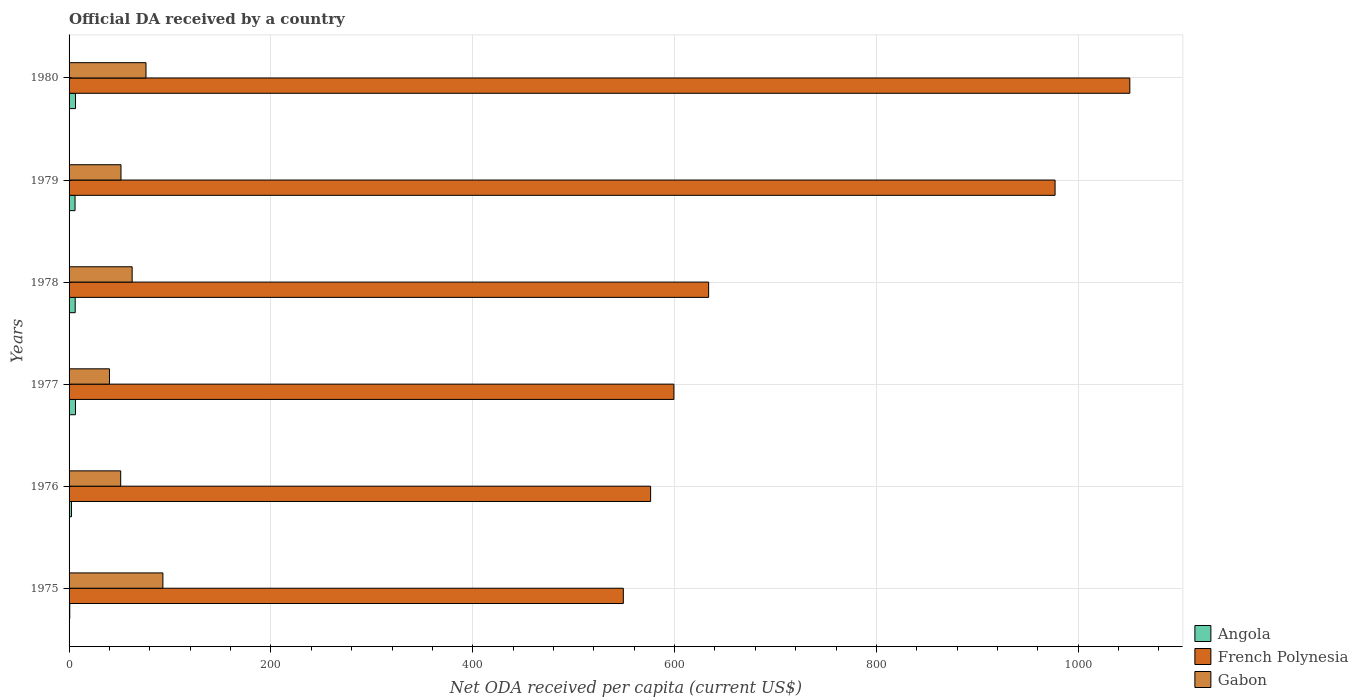How many groups of bars are there?
Your answer should be compact. 6. Are the number of bars per tick equal to the number of legend labels?
Give a very brief answer. Yes. What is the label of the 5th group of bars from the top?
Your answer should be very brief. 1976. What is the ODA received in in Gabon in 1979?
Your response must be concise. 51.47. Across all years, what is the maximum ODA received in in Gabon?
Offer a terse response. 92.96. Across all years, what is the minimum ODA received in in French Polynesia?
Make the answer very short. 549.23. In which year was the ODA received in in French Polynesia maximum?
Keep it short and to the point. 1980. What is the total ODA received in in Gabon in the graph?
Ensure brevity in your answer.  374.36. What is the difference between the ODA received in in French Polynesia in 1976 and that in 1980?
Your answer should be compact. -474.86. What is the difference between the ODA received in in Gabon in 1979 and the ODA received in in French Polynesia in 1980?
Keep it short and to the point. -999.67. What is the average ODA received in in Gabon per year?
Offer a very short reply. 62.39. In the year 1979, what is the difference between the ODA received in in Angola and ODA received in in French Polynesia?
Offer a terse response. -971.14. What is the ratio of the ODA received in in French Polynesia in 1975 to that in 1980?
Provide a succinct answer. 0.52. Is the ODA received in in French Polynesia in 1976 less than that in 1980?
Your answer should be very brief. Yes. Is the difference between the ODA received in in Angola in 1976 and 1980 greater than the difference between the ODA received in in French Polynesia in 1976 and 1980?
Your answer should be very brief. Yes. What is the difference between the highest and the second highest ODA received in in French Polynesia?
Provide a succinct answer. 74.08. What is the difference between the highest and the lowest ODA received in in Angola?
Offer a very short reply. 5.72. In how many years, is the ODA received in in French Polynesia greater than the average ODA received in in French Polynesia taken over all years?
Offer a terse response. 2. Is the sum of the ODA received in in French Polynesia in 1975 and 1980 greater than the maximum ODA received in in Angola across all years?
Make the answer very short. Yes. What does the 2nd bar from the top in 1976 represents?
Your answer should be compact. French Polynesia. What does the 1st bar from the bottom in 1975 represents?
Offer a very short reply. Angola. How many bars are there?
Offer a terse response. 18. Are the values on the major ticks of X-axis written in scientific E-notation?
Provide a short and direct response. No. Does the graph contain grids?
Offer a very short reply. Yes. How many legend labels are there?
Your answer should be very brief. 3. What is the title of the graph?
Your response must be concise. Official DA received by a country. Does "Costa Rica" appear as one of the legend labels in the graph?
Provide a succinct answer. No. What is the label or title of the X-axis?
Offer a very short reply. Net ODA received per capita (current US$). What is the Net ODA received per capita (current US$) of Angola in 1975?
Make the answer very short. 0.67. What is the Net ODA received per capita (current US$) of French Polynesia in 1975?
Your answer should be compact. 549.23. What is the Net ODA received per capita (current US$) of Gabon in 1975?
Give a very brief answer. 92.96. What is the Net ODA received per capita (current US$) of Angola in 1976?
Offer a terse response. 2.39. What is the Net ODA received per capita (current US$) of French Polynesia in 1976?
Your answer should be very brief. 576.28. What is the Net ODA received per capita (current US$) of Gabon in 1976?
Your response must be concise. 51.16. What is the Net ODA received per capita (current US$) of Angola in 1977?
Provide a short and direct response. 6.33. What is the Net ODA received per capita (current US$) of French Polynesia in 1977?
Make the answer very short. 599.35. What is the Net ODA received per capita (current US$) of Gabon in 1977?
Provide a succinct answer. 40.03. What is the Net ODA received per capita (current US$) in Angola in 1978?
Keep it short and to the point. 6.07. What is the Net ODA received per capita (current US$) in French Polynesia in 1978?
Keep it short and to the point. 633.77. What is the Net ODA received per capita (current US$) of Gabon in 1978?
Your response must be concise. 62.51. What is the Net ODA received per capita (current US$) in Angola in 1979?
Offer a terse response. 5.92. What is the Net ODA received per capita (current US$) of French Polynesia in 1979?
Provide a succinct answer. 977.06. What is the Net ODA received per capita (current US$) in Gabon in 1979?
Your answer should be very brief. 51.47. What is the Net ODA received per capita (current US$) of Angola in 1980?
Make the answer very short. 6.39. What is the Net ODA received per capita (current US$) in French Polynesia in 1980?
Make the answer very short. 1051.14. What is the Net ODA received per capita (current US$) of Gabon in 1980?
Give a very brief answer. 76.22. Across all years, what is the maximum Net ODA received per capita (current US$) in Angola?
Provide a succinct answer. 6.39. Across all years, what is the maximum Net ODA received per capita (current US$) of French Polynesia?
Give a very brief answer. 1051.14. Across all years, what is the maximum Net ODA received per capita (current US$) in Gabon?
Your response must be concise. 92.96. Across all years, what is the minimum Net ODA received per capita (current US$) of Angola?
Make the answer very short. 0.67. Across all years, what is the minimum Net ODA received per capita (current US$) of French Polynesia?
Keep it short and to the point. 549.23. Across all years, what is the minimum Net ODA received per capita (current US$) of Gabon?
Your answer should be very brief. 40.03. What is the total Net ODA received per capita (current US$) in Angola in the graph?
Offer a very short reply. 27.77. What is the total Net ODA received per capita (current US$) in French Polynesia in the graph?
Make the answer very short. 4386.83. What is the total Net ODA received per capita (current US$) in Gabon in the graph?
Give a very brief answer. 374.36. What is the difference between the Net ODA received per capita (current US$) of Angola in 1975 and that in 1976?
Offer a very short reply. -1.73. What is the difference between the Net ODA received per capita (current US$) in French Polynesia in 1975 and that in 1976?
Your answer should be compact. -27.05. What is the difference between the Net ODA received per capita (current US$) in Gabon in 1975 and that in 1976?
Offer a very short reply. 41.8. What is the difference between the Net ODA received per capita (current US$) in Angola in 1975 and that in 1977?
Offer a terse response. -5.66. What is the difference between the Net ODA received per capita (current US$) of French Polynesia in 1975 and that in 1977?
Your response must be concise. -50.12. What is the difference between the Net ODA received per capita (current US$) in Gabon in 1975 and that in 1977?
Your answer should be very brief. 52.94. What is the difference between the Net ODA received per capita (current US$) of Angola in 1975 and that in 1978?
Keep it short and to the point. -5.4. What is the difference between the Net ODA received per capita (current US$) of French Polynesia in 1975 and that in 1978?
Offer a very short reply. -84.54. What is the difference between the Net ODA received per capita (current US$) in Gabon in 1975 and that in 1978?
Offer a very short reply. 30.45. What is the difference between the Net ODA received per capita (current US$) of Angola in 1975 and that in 1979?
Provide a succinct answer. -5.25. What is the difference between the Net ODA received per capita (current US$) in French Polynesia in 1975 and that in 1979?
Your answer should be compact. -427.83. What is the difference between the Net ODA received per capita (current US$) of Gabon in 1975 and that in 1979?
Ensure brevity in your answer.  41.5. What is the difference between the Net ODA received per capita (current US$) in Angola in 1975 and that in 1980?
Your response must be concise. -5.72. What is the difference between the Net ODA received per capita (current US$) in French Polynesia in 1975 and that in 1980?
Provide a succinct answer. -501.91. What is the difference between the Net ODA received per capita (current US$) of Gabon in 1975 and that in 1980?
Offer a very short reply. 16.74. What is the difference between the Net ODA received per capita (current US$) in Angola in 1976 and that in 1977?
Offer a very short reply. -3.94. What is the difference between the Net ODA received per capita (current US$) in French Polynesia in 1976 and that in 1977?
Ensure brevity in your answer.  -23.07. What is the difference between the Net ODA received per capita (current US$) of Gabon in 1976 and that in 1977?
Provide a succinct answer. 11.13. What is the difference between the Net ODA received per capita (current US$) of Angola in 1976 and that in 1978?
Ensure brevity in your answer.  -3.68. What is the difference between the Net ODA received per capita (current US$) in French Polynesia in 1976 and that in 1978?
Provide a short and direct response. -57.49. What is the difference between the Net ODA received per capita (current US$) in Gabon in 1976 and that in 1978?
Give a very brief answer. -11.35. What is the difference between the Net ODA received per capita (current US$) in Angola in 1976 and that in 1979?
Offer a terse response. -3.52. What is the difference between the Net ODA received per capita (current US$) in French Polynesia in 1976 and that in 1979?
Offer a very short reply. -400.78. What is the difference between the Net ODA received per capita (current US$) of Gabon in 1976 and that in 1979?
Offer a very short reply. -0.3. What is the difference between the Net ODA received per capita (current US$) in Angola in 1976 and that in 1980?
Provide a succinct answer. -3.99. What is the difference between the Net ODA received per capita (current US$) in French Polynesia in 1976 and that in 1980?
Make the answer very short. -474.86. What is the difference between the Net ODA received per capita (current US$) of Gabon in 1976 and that in 1980?
Make the answer very short. -25.06. What is the difference between the Net ODA received per capita (current US$) in Angola in 1977 and that in 1978?
Provide a succinct answer. 0.26. What is the difference between the Net ODA received per capita (current US$) of French Polynesia in 1977 and that in 1978?
Offer a terse response. -34.42. What is the difference between the Net ODA received per capita (current US$) of Gabon in 1977 and that in 1978?
Provide a succinct answer. -22.49. What is the difference between the Net ODA received per capita (current US$) in Angola in 1977 and that in 1979?
Make the answer very short. 0.41. What is the difference between the Net ODA received per capita (current US$) in French Polynesia in 1977 and that in 1979?
Keep it short and to the point. -377.71. What is the difference between the Net ODA received per capita (current US$) of Gabon in 1977 and that in 1979?
Offer a terse response. -11.44. What is the difference between the Net ODA received per capita (current US$) of Angola in 1977 and that in 1980?
Your response must be concise. -0.05. What is the difference between the Net ODA received per capita (current US$) in French Polynesia in 1977 and that in 1980?
Give a very brief answer. -451.79. What is the difference between the Net ODA received per capita (current US$) in Gabon in 1977 and that in 1980?
Your answer should be compact. -36.2. What is the difference between the Net ODA received per capita (current US$) of Angola in 1978 and that in 1979?
Provide a short and direct response. 0.16. What is the difference between the Net ODA received per capita (current US$) in French Polynesia in 1978 and that in 1979?
Make the answer very short. -343.29. What is the difference between the Net ODA received per capita (current US$) in Gabon in 1978 and that in 1979?
Ensure brevity in your answer.  11.05. What is the difference between the Net ODA received per capita (current US$) in Angola in 1978 and that in 1980?
Provide a succinct answer. -0.31. What is the difference between the Net ODA received per capita (current US$) in French Polynesia in 1978 and that in 1980?
Keep it short and to the point. -417.37. What is the difference between the Net ODA received per capita (current US$) of Gabon in 1978 and that in 1980?
Offer a very short reply. -13.71. What is the difference between the Net ODA received per capita (current US$) of Angola in 1979 and that in 1980?
Offer a terse response. -0.47. What is the difference between the Net ODA received per capita (current US$) of French Polynesia in 1979 and that in 1980?
Make the answer very short. -74.08. What is the difference between the Net ODA received per capita (current US$) in Gabon in 1979 and that in 1980?
Make the answer very short. -24.76. What is the difference between the Net ODA received per capita (current US$) in Angola in 1975 and the Net ODA received per capita (current US$) in French Polynesia in 1976?
Provide a succinct answer. -575.61. What is the difference between the Net ODA received per capita (current US$) of Angola in 1975 and the Net ODA received per capita (current US$) of Gabon in 1976?
Provide a short and direct response. -50.49. What is the difference between the Net ODA received per capita (current US$) in French Polynesia in 1975 and the Net ODA received per capita (current US$) in Gabon in 1976?
Provide a short and direct response. 498.07. What is the difference between the Net ODA received per capita (current US$) in Angola in 1975 and the Net ODA received per capita (current US$) in French Polynesia in 1977?
Offer a very short reply. -598.68. What is the difference between the Net ODA received per capita (current US$) of Angola in 1975 and the Net ODA received per capita (current US$) of Gabon in 1977?
Give a very brief answer. -39.36. What is the difference between the Net ODA received per capita (current US$) in French Polynesia in 1975 and the Net ODA received per capita (current US$) in Gabon in 1977?
Give a very brief answer. 509.2. What is the difference between the Net ODA received per capita (current US$) of Angola in 1975 and the Net ODA received per capita (current US$) of French Polynesia in 1978?
Your answer should be very brief. -633.1. What is the difference between the Net ODA received per capita (current US$) in Angola in 1975 and the Net ODA received per capita (current US$) in Gabon in 1978?
Make the answer very short. -61.84. What is the difference between the Net ODA received per capita (current US$) of French Polynesia in 1975 and the Net ODA received per capita (current US$) of Gabon in 1978?
Give a very brief answer. 486.72. What is the difference between the Net ODA received per capita (current US$) in Angola in 1975 and the Net ODA received per capita (current US$) in French Polynesia in 1979?
Give a very brief answer. -976.39. What is the difference between the Net ODA received per capita (current US$) in Angola in 1975 and the Net ODA received per capita (current US$) in Gabon in 1979?
Ensure brevity in your answer.  -50.8. What is the difference between the Net ODA received per capita (current US$) in French Polynesia in 1975 and the Net ODA received per capita (current US$) in Gabon in 1979?
Offer a very short reply. 497.77. What is the difference between the Net ODA received per capita (current US$) in Angola in 1975 and the Net ODA received per capita (current US$) in French Polynesia in 1980?
Offer a very short reply. -1050.47. What is the difference between the Net ODA received per capita (current US$) of Angola in 1975 and the Net ODA received per capita (current US$) of Gabon in 1980?
Your answer should be very brief. -75.55. What is the difference between the Net ODA received per capita (current US$) of French Polynesia in 1975 and the Net ODA received per capita (current US$) of Gabon in 1980?
Make the answer very short. 473.01. What is the difference between the Net ODA received per capita (current US$) of Angola in 1976 and the Net ODA received per capita (current US$) of French Polynesia in 1977?
Your answer should be compact. -596.96. What is the difference between the Net ODA received per capita (current US$) in Angola in 1976 and the Net ODA received per capita (current US$) in Gabon in 1977?
Offer a very short reply. -37.63. What is the difference between the Net ODA received per capita (current US$) in French Polynesia in 1976 and the Net ODA received per capita (current US$) in Gabon in 1977?
Provide a succinct answer. 536.25. What is the difference between the Net ODA received per capita (current US$) in Angola in 1976 and the Net ODA received per capita (current US$) in French Polynesia in 1978?
Provide a short and direct response. -631.38. What is the difference between the Net ODA received per capita (current US$) in Angola in 1976 and the Net ODA received per capita (current US$) in Gabon in 1978?
Ensure brevity in your answer.  -60.12. What is the difference between the Net ODA received per capita (current US$) of French Polynesia in 1976 and the Net ODA received per capita (current US$) of Gabon in 1978?
Keep it short and to the point. 513.77. What is the difference between the Net ODA received per capita (current US$) in Angola in 1976 and the Net ODA received per capita (current US$) in French Polynesia in 1979?
Give a very brief answer. -974.67. What is the difference between the Net ODA received per capita (current US$) in Angola in 1976 and the Net ODA received per capita (current US$) in Gabon in 1979?
Offer a terse response. -49.07. What is the difference between the Net ODA received per capita (current US$) of French Polynesia in 1976 and the Net ODA received per capita (current US$) of Gabon in 1979?
Offer a very short reply. 524.82. What is the difference between the Net ODA received per capita (current US$) of Angola in 1976 and the Net ODA received per capita (current US$) of French Polynesia in 1980?
Provide a short and direct response. -1048.75. What is the difference between the Net ODA received per capita (current US$) in Angola in 1976 and the Net ODA received per capita (current US$) in Gabon in 1980?
Give a very brief answer. -73.83. What is the difference between the Net ODA received per capita (current US$) of French Polynesia in 1976 and the Net ODA received per capita (current US$) of Gabon in 1980?
Your answer should be compact. 500.06. What is the difference between the Net ODA received per capita (current US$) in Angola in 1977 and the Net ODA received per capita (current US$) in French Polynesia in 1978?
Make the answer very short. -627.44. What is the difference between the Net ODA received per capita (current US$) of Angola in 1977 and the Net ODA received per capita (current US$) of Gabon in 1978?
Your response must be concise. -56.18. What is the difference between the Net ODA received per capita (current US$) in French Polynesia in 1977 and the Net ODA received per capita (current US$) in Gabon in 1978?
Your answer should be very brief. 536.84. What is the difference between the Net ODA received per capita (current US$) in Angola in 1977 and the Net ODA received per capita (current US$) in French Polynesia in 1979?
Offer a terse response. -970.73. What is the difference between the Net ODA received per capita (current US$) of Angola in 1977 and the Net ODA received per capita (current US$) of Gabon in 1979?
Your response must be concise. -45.13. What is the difference between the Net ODA received per capita (current US$) in French Polynesia in 1977 and the Net ODA received per capita (current US$) in Gabon in 1979?
Offer a terse response. 547.88. What is the difference between the Net ODA received per capita (current US$) of Angola in 1977 and the Net ODA received per capita (current US$) of French Polynesia in 1980?
Your answer should be compact. -1044.81. What is the difference between the Net ODA received per capita (current US$) in Angola in 1977 and the Net ODA received per capita (current US$) in Gabon in 1980?
Your response must be concise. -69.89. What is the difference between the Net ODA received per capita (current US$) in French Polynesia in 1977 and the Net ODA received per capita (current US$) in Gabon in 1980?
Your answer should be very brief. 523.13. What is the difference between the Net ODA received per capita (current US$) in Angola in 1978 and the Net ODA received per capita (current US$) in French Polynesia in 1979?
Keep it short and to the point. -970.99. What is the difference between the Net ODA received per capita (current US$) of Angola in 1978 and the Net ODA received per capita (current US$) of Gabon in 1979?
Provide a short and direct response. -45.39. What is the difference between the Net ODA received per capita (current US$) in French Polynesia in 1978 and the Net ODA received per capita (current US$) in Gabon in 1979?
Your response must be concise. 582.3. What is the difference between the Net ODA received per capita (current US$) of Angola in 1978 and the Net ODA received per capita (current US$) of French Polynesia in 1980?
Provide a succinct answer. -1045.07. What is the difference between the Net ODA received per capita (current US$) in Angola in 1978 and the Net ODA received per capita (current US$) in Gabon in 1980?
Keep it short and to the point. -70.15. What is the difference between the Net ODA received per capita (current US$) in French Polynesia in 1978 and the Net ODA received per capita (current US$) in Gabon in 1980?
Your response must be concise. 557.55. What is the difference between the Net ODA received per capita (current US$) in Angola in 1979 and the Net ODA received per capita (current US$) in French Polynesia in 1980?
Your answer should be compact. -1045.22. What is the difference between the Net ODA received per capita (current US$) of Angola in 1979 and the Net ODA received per capita (current US$) of Gabon in 1980?
Your answer should be compact. -70.31. What is the difference between the Net ODA received per capita (current US$) in French Polynesia in 1979 and the Net ODA received per capita (current US$) in Gabon in 1980?
Make the answer very short. 900.84. What is the average Net ODA received per capita (current US$) of Angola per year?
Provide a short and direct response. 4.63. What is the average Net ODA received per capita (current US$) in French Polynesia per year?
Offer a very short reply. 731.14. What is the average Net ODA received per capita (current US$) in Gabon per year?
Offer a terse response. 62.39. In the year 1975, what is the difference between the Net ODA received per capita (current US$) in Angola and Net ODA received per capita (current US$) in French Polynesia?
Provide a short and direct response. -548.56. In the year 1975, what is the difference between the Net ODA received per capita (current US$) in Angola and Net ODA received per capita (current US$) in Gabon?
Offer a very short reply. -92.29. In the year 1975, what is the difference between the Net ODA received per capita (current US$) of French Polynesia and Net ODA received per capita (current US$) of Gabon?
Give a very brief answer. 456.27. In the year 1976, what is the difference between the Net ODA received per capita (current US$) of Angola and Net ODA received per capita (current US$) of French Polynesia?
Ensure brevity in your answer.  -573.89. In the year 1976, what is the difference between the Net ODA received per capita (current US$) in Angola and Net ODA received per capita (current US$) in Gabon?
Your answer should be compact. -48.77. In the year 1976, what is the difference between the Net ODA received per capita (current US$) in French Polynesia and Net ODA received per capita (current US$) in Gabon?
Give a very brief answer. 525.12. In the year 1977, what is the difference between the Net ODA received per capita (current US$) of Angola and Net ODA received per capita (current US$) of French Polynesia?
Offer a very short reply. -593.02. In the year 1977, what is the difference between the Net ODA received per capita (current US$) in Angola and Net ODA received per capita (current US$) in Gabon?
Your answer should be very brief. -33.7. In the year 1977, what is the difference between the Net ODA received per capita (current US$) of French Polynesia and Net ODA received per capita (current US$) of Gabon?
Your response must be concise. 559.32. In the year 1978, what is the difference between the Net ODA received per capita (current US$) in Angola and Net ODA received per capita (current US$) in French Polynesia?
Ensure brevity in your answer.  -627.7. In the year 1978, what is the difference between the Net ODA received per capita (current US$) of Angola and Net ODA received per capita (current US$) of Gabon?
Make the answer very short. -56.44. In the year 1978, what is the difference between the Net ODA received per capita (current US$) in French Polynesia and Net ODA received per capita (current US$) in Gabon?
Keep it short and to the point. 571.26. In the year 1979, what is the difference between the Net ODA received per capita (current US$) of Angola and Net ODA received per capita (current US$) of French Polynesia?
Offer a terse response. -971.14. In the year 1979, what is the difference between the Net ODA received per capita (current US$) in Angola and Net ODA received per capita (current US$) in Gabon?
Give a very brief answer. -45.55. In the year 1979, what is the difference between the Net ODA received per capita (current US$) of French Polynesia and Net ODA received per capita (current US$) of Gabon?
Make the answer very short. 925.59. In the year 1980, what is the difference between the Net ODA received per capita (current US$) in Angola and Net ODA received per capita (current US$) in French Polynesia?
Your response must be concise. -1044.75. In the year 1980, what is the difference between the Net ODA received per capita (current US$) in Angola and Net ODA received per capita (current US$) in Gabon?
Ensure brevity in your answer.  -69.84. In the year 1980, what is the difference between the Net ODA received per capita (current US$) in French Polynesia and Net ODA received per capita (current US$) in Gabon?
Give a very brief answer. 974.92. What is the ratio of the Net ODA received per capita (current US$) of Angola in 1975 to that in 1976?
Ensure brevity in your answer.  0.28. What is the ratio of the Net ODA received per capita (current US$) in French Polynesia in 1975 to that in 1976?
Give a very brief answer. 0.95. What is the ratio of the Net ODA received per capita (current US$) in Gabon in 1975 to that in 1976?
Make the answer very short. 1.82. What is the ratio of the Net ODA received per capita (current US$) in Angola in 1975 to that in 1977?
Provide a succinct answer. 0.11. What is the ratio of the Net ODA received per capita (current US$) in French Polynesia in 1975 to that in 1977?
Ensure brevity in your answer.  0.92. What is the ratio of the Net ODA received per capita (current US$) in Gabon in 1975 to that in 1977?
Your answer should be compact. 2.32. What is the ratio of the Net ODA received per capita (current US$) in Angola in 1975 to that in 1978?
Keep it short and to the point. 0.11. What is the ratio of the Net ODA received per capita (current US$) in French Polynesia in 1975 to that in 1978?
Provide a short and direct response. 0.87. What is the ratio of the Net ODA received per capita (current US$) in Gabon in 1975 to that in 1978?
Your answer should be compact. 1.49. What is the ratio of the Net ODA received per capita (current US$) of Angola in 1975 to that in 1979?
Your response must be concise. 0.11. What is the ratio of the Net ODA received per capita (current US$) of French Polynesia in 1975 to that in 1979?
Give a very brief answer. 0.56. What is the ratio of the Net ODA received per capita (current US$) of Gabon in 1975 to that in 1979?
Offer a very short reply. 1.81. What is the ratio of the Net ODA received per capita (current US$) of Angola in 1975 to that in 1980?
Provide a short and direct response. 0.1. What is the ratio of the Net ODA received per capita (current US$) in French Polynesia in 1975 to that in 1980?
Ensure brevity in your answer.  0.52. What is the ratio of the Net ODA received per capita (current US$) of Gabon in 1975 to that in 1980?
Provide a succinct answer. 1.22. What is the ratio of the Net ODA received per capita (current US$) of Angola in 1976 to that in 1977?
Offer a terse response. 0.38. What is the ratio of the Net ODA received per capita (current US$) of French Polynesia in 1976 to that in 1977?
Your answer should be compact. 0.96. What is the ratio of the Net ODA received per capita (current US$) in Gabon in 1976 to that in 1977?
Give a very brief answer. 1.28. What is the ratio of the Net ODA received per capita (current US$) in Angola in 1976 to that in 1978?
Provide a short and direct response. 0.39. What is the ratio of the Net ODA received per capita (current US$) of French Polynesia in 1976 to that in 1978?
Your response must be concise. 0.91. What is the ratio of the Net ODA received per capita (current US$) of Gabon in 1976 to that in 1978?
Offer a very short reply. 0.82. What is the ratio of the Net ODA received per capita (current US$) in Angola in 1976 to that in 1979?
Your answer should be very brief. 0.4. What is the ratio of the Net ODA received per capita (current US$) of French Polynesia in 1976 to that in 1979?
Offer a very short reply. 0.59. What is the ratio of the Net ODA received per capita (current US$) of Angola in 1976 to that in 1980?
Ensure brevity in your answer.  0.38. What is the ratio of the Net ODA received per capita (current US$) in French Polynesia in 1976 to that in 1980?
Ensure brevity in your answer.  0.55. What is the ratio of the Net ODA received per capita (current US$) of Gabon in 1976 to that in 1980?
Offer a terse response. 0.67. What is the ratio of the Net ODA received per capita (current US$) in Angola in 1977 to that in 1978?
Provide a short and direct response. 1.04. What is the ratio of the Net ODA received per capita (current US$) in French Polynesia in 1977 to that in 1978?
Your answer should be compact. 0.95. What is the ratio of the Net ODA received per capita (current US$) in Gabon in 1977 to that in 1978?
Make the answer very short. 0.64. What is the ratio of the Net ODA received per capita (current US$) of Angola in 1977 to that in 1979?
Ensure brevity in your answer.  1.07. What is the ratio of the Net ODA received per capita (current US$) in French Polynesia in 1977 to that in 1979?
Offer a terse response. 0.61. What is the ratio of the Net ODA received per capita (current US$) of French Polynesia in 1977 to that in 1980?
Provide a succinct answer. 0.57. What is the ratio of the Net ODA received per capita (current US$) in Gabon in 1977 to that in 1980?
Your response must be concise. 0.53. What is the ratio of the Net ODA received per capita (current US$) in Angola in 1978 to that in 1979?
Give a very brief answer. 1.03. What is the ratio of the Net ODA received per capita (current US$) in French Polynesia in 1978 to that in 1979?
Keep it short and to the point. 0.65. What is the ratio of the Net ODA received per capita (current US$) in Gabon in 1978 to that in 1979?
Provide a succinct answer. 1.21. What is the ratio of the Net ODA received per capita (current US$) in Angola in 1978 to that in 1980?
Give a very brief answer. 0.95. What is the ratio of the Net ODA received per capita (current US$) of French Polynesia in 1978 to that in 1980?
Provide a short and direct response. 0.6. What is the ratio of the Net ODA received per capita (current US$) of Gabon in 1978 to that in 1980?
Offer a terse response. 0.82. What is the ratio of the Net ODA received per capita (current US$) in Angola in 1979 to that in 1980?
Your answer should be compact. 0.93. What is the ratio of the Net ODA received per capita (current US$) of French Polynesia in 1979 to that in 1980?
Keep it short and to the point. 0.93. What is the ratio of the Net ODA received per capita (current US$) in Gabon in 1979 to that in 1980?
Your answer should be very brief. 0.68. What is the difference between the highest and the second highest Net ODA received per capita (current US$) in Angola?
Make the answer very short. 0.05. What is the difference between the highest and the second highest Net ODA received per capita (current US$) in French Polynesia?
Give a very brief answer. 74.08. What is the difference between the highest and the second highest Net ODA received per capita (current US$) of Gabon?
Offer a terse response. 16.74. What is the difference between the highest and the lowest Net ODA received per capita (current US$) of Angola?
Give a very brief answer. 5.72. What is the difference between the highest and the lowest Net ODA received per capita (current US$) in French Polynesia?
Give a very brief answer. 501.91. What is the difference between the highest and the lowest Net ODA received per capita (current US$) in Gabon?
Provide a short and direct response. 52.94. 